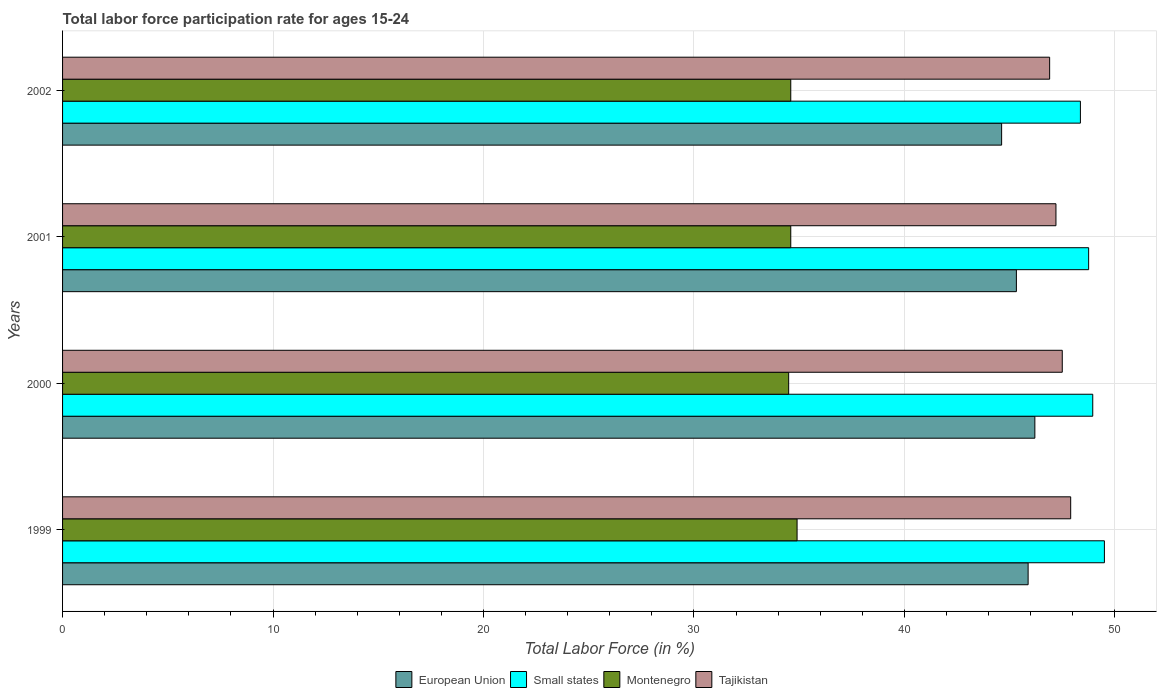Are the number of bars per tick equal to the number of legend labels?
Give a very brief answer. Yes. Are the number of bars on each tick of the Y-axis equal?
Give a very brief answer. Yes. How many bars are there on the 1st tick from the bottom?
Keep it short and to the point. 4. What is the labor force participation rate in European Union in 2000?
Offer a terse response. 46.2. Across all years, what is the maximum labor force participation rate in Small states?
Offer a very short reply. 49.5. Across all years, what is the minimum labor force participation rate in European Union?
Make the answer very short. 44.62. In which year was the labor force participation rate in Small states maximum?
Give a very brief answer. 1999. What is the total labor force participation rate in European Union in the graph?
Provide a short and direct response. 182.01. What is the difference between the labor force participation rate in Tajikistan in 2000 and that in 2001?
Give a very brief answer. 0.3. What is the difference between the labor force participation rate in Tajikistan in 1999 and the labor force participation rate in Montenegro in 2001?
Make the answer very short. 13.3. What is the average labor force participation rate in Small states per year?
Provide a short and direct response. 48.89. In the year 2000, what is the difference between the labor force participation rate in Montenegro and labor force participation rate in European Union?
Ensure brevity in your answer.  -11.7. In how many years, is the labor force participation rate in European Union greater than 2 %?
Offer a very short reply. 4. What is the ratio of the labor force participation rate in Montenegro in 1999 to that in 2002?
Offer a very short reply. 1.01. Is the labor force participation rate in Montenegro in 1999 less than that in 2000?
Provide a short and direct response. No. Is the difference between the labor force participation rate in Montenegro in 1999 and 2001 greater than the difference between the labor force participation rate in European Union in 1999 and 2001?
Provide a succinct answer. No. What is the difference between the highest and the second highest labor force participation rate in European Union?
Ensure brevity in your answer.  0.32. What is the difference between the highest and the lowest labor force participation rate in Tajikistan?
Your response must be concise. 1. In how many years, is the labor force participation rate in Tajikistan greater than the average labor force participation rate in Tajikistan taken over all years?
Your answer should be compact. 2. Is the sum of the labor force participation rate in Montenegro in 2000 and 2002 greater than the maximum labor force participation rate in Tajikistan across all years?
Your response must be concise. Yes. Is it the case that in every year, the sum of the labor force participation rate in European Union and labor force participation rate in Montenegro is greater than the sum of labor force participation rate in Small states and labor force participation rate in Tajikistan?
Offer a terse response. No. What does the 3rd bar from the top in 1999 represents?
Your response must be concise. Small states. What does the 4th bar from the bottom in 2001 represents?
Your answer should be very brief. Tajikistan. Is it the case that in every year, the sum of the labor force participation rate in Montenegro and labor force participation rate in European Union is greater than the labor force participation rate in Tajikistan?
Offer a very short reply. Yes. How many bars are there?
Offer a terse response. 16. What is the difference between two consecutive major ticks on the X-axis?
Make the answer very short. 10. Does the graph contain any zero values?
Make the answer very short. No. Does the graph contain grids?
Keep it short and to the point. Yes. How are the legend labels stacked?
Offer a very short reply. Horizontal. What is the title of the graph?
Your answer should be compact. Total labor force participation rate for ages 15-24. Does "South Asia" appear as one of the legend labels in the graph?
Provide a succinct answer. No. What is the label or title of the Y-axis?
Provide a short and direct response. Years. What is the Total Labor Force (in %) of European Union in 1999?
Keep it short and to the point. 45.88. What is the Total Labor Force (in %) of Small states in 1999?
Keep it short and to the point. 49.5. What is the Total Labor Force (in %) of Montenegro in 1999?
Your response must be concise. 34.9. What is the Total Labor Force (in %) of Tajikistan in 1999?
Your answer should be very brief. 47.9. What is the Total Labor Force (in %) in European Union in 2000?
Make the answer very short. 46.2. What is the Total Labor Force (in %) of Small states in 2000?
Provide a short and direct response. 48.95. What is the Total Labor Force (in %) of Montenegro in 2000?
Give a very brief answer. 34.5. What is the Total Labor Force (in %) in Tajikistan in 2000?
Provide a succinct answer. 47.5. What is the Total Labor Force (in %) of European Union in 2001?
Provide a short and direct response. 45.32. What is the Total Labor Force (in %) in Small states in 2001?
Offer a terse response. 48.75. What is the Total Labor Force (in %) of Montenegro in 2001?
Provide a succinct answer. 34.6. What is the Total Labor Force (in %) in Tajikistan in 2001?
Keep it short and to the point. 47.2. What is the Total Labor Force (in %) in European Union in 2002?
Ensure brevity in your answer.  44.62. What is the Total Labor Force (in %) of Small states in 2002?
Offer a terse response. 48.36. What is the Total Labor Force (in %) of Montenegro in 2002?
Keep it short and to the point. 34.6. What is the Total Labor Force (in %) of Tajikistan in 2002?
Keep it short and to the point. 46.9. Across all years, what is the maximum Total Labor Force (in %) in European Union?
Make the answer very short. 46.2. Across all years, what is the maximum Total Labor Force (in %) in Small states?
Offer a terse response. 49.5. Across all years, what is the maximum Total Labor Force (in %) of Montenegro?
Keep it short and to the point. 34.9. Across all years, what is the maximum Total Labor Force (in %) of Tajikistan?
Your response must be concise. 47.9. Across all years, what is the minimum Total Labor Force (in %) of European Union?
Make the answer very short. 44.62. Across all years, what is the minimum Total Labor Force (in %) in Small states?
Your answer should be compact. 48.36. Across all years, what is the minimum Total Labor Force (in %) of Montenegro?
Offer a terse response. 34.5. Across all years, what is the minimum Total Labor Force (in %) in Tajikistan?
Keep it short and to the point. 46.9. What is the total Total Labor Force (in %) of European Union in the graph?
Provide a succinct answer. 182.01. What is the total Total Labor Force (in %) in Small states in the graph?
Ensure brevity in your answer.  195.56. What is the total Total Labor Force (in %) in Montenegro in the graph?
Ensure brevity in your answer.  138.6. What is the total Total Labor Force (in %) in Tajikistan in the graph?
Provide a short and direct response. 189.5. What is the difference between the Total Labor Force (in %) in European Union in 1999 and that in 2000?
Offer a terse response. -0.32. What is the difference between the Total Labor Force (in %) of Small states in 1999 and that in 2000?
Your response must be concise. 0.55. What is the difference between the Total Labor Force (in %) of European Union in 1999 and that in 2001?
Offer a very short reply. 0.56. What is the difference between the Total Labor Force (in %) of Small states in 1999 and that in 2001?
Offer a terse response. 0.75. What is the difference between the Total Labor Force (in %) in Montenegro in 1999 and that in 2001?
Ensure brevity in your answer.  0.3. What is the difference between the Total Labor Force (in %) of European Union in 1999 and that in 2002?
Offer a terse response. 1.26. What is the difference between the Total Labor Force (in %) of Small states in 1999 and that in 2002?
Your response must be concise. 1.14. What is the difference between the Total Labor Force (in %) in Montenegro in 1999 and that in 2002?
Keep it short and to the point. 0.3. What is the difference between the Total Labor Force (in %) of European Union in 2000 and that in 2001?
Your answer should be compact. 0.88. What is the difference between the Total Labor Force (in %) in Small states in 2000 and that in 2001?
Your answer should be compact. 0.19. What is the difference between the Total Labor Force (in %) in Montenegro in 2000 and that in 2001?
Your answer should be compact. -0.1. What is the difference between the Total Labor Force (in %) in Tajikistan in 2000 and that in 2001?
Provide a short and direct response. 0.3. What is the difference between the Total Labor Force (in %) of European Union in 2000 and that in 2002?
Ensure brevity in your answer.  1.58. What is the difference between the Total Labor Force (in %) of Small states in 2000 and that in 2002?
Keep it short and to the point. 0.59. What is the difference between the Total Labor Force (in %) in European Union in 2001 and that in 2002?
Keep it short and to the point. 0.7. What is the difference between the Total Labor Force (in %) of Small states in 2001 and that in 2002?
Keep it short and to the point. 0.39. What is the difference between the Total Labor Force (in %) in Montenegro in 2001 and that in 2002?
Your answer should be compact. 0. What is the difference between the Total Labor Force (in %) of Tajikistan in 2001 and that in 2002?
Keep it short and to the point. 0.3. What is the difference between the Total Labor Force (in %) of European Union in 1999 and the Total Labor Force (in %) of Small states in 2000?
Your answer should be compact. -3.07. What is the difference between the Total Labor Force (in %) in European Union in 1999 and the Total Labor Force (in %) in Montenegro in 2000?
Provide a short and direct response. 11.38. What is the difference between the Total Labor Force (in %) of European Union in 1999 and the Total Labor Force (in %) of Tajikistan in 2000?
Your answer should be compact. -1.62. What is the difference between the Total Labor Force (in %) in Small states in 1999 and the Total Labor Force (in %) in Montenegro in 2000?
Ensure brevity in your answer.  15. What is the difference between the Total Labor Force (in %) of Small states in 1999 and the Total Labor Force (in %) of Tajikistan in 2000?
Give a very brief answer. 2. What is the difference between the Total Labor Force (in %) in European Union in 1999 and the Total Labor Force (in %) in Small states in 2001?
Give a very brief answer. -2.88. What is the difference between the Total Labor Force (in %) in European Union in 1999 and the Total Labor Force (in %) in Montenegro in 2001?
Your answer should be compact. 11.28. What is the difference between the Total Labor Force (in %) of European Union in 1999 and the Total Labor Force (in %) of Tajikistan in 2001?
Your answer should be compact. -1.32. What is the difference between the Total Labor Force (in %) in Small states in 1999 and the Total Labor Force (in %) in Montenegro in 2001?
Make the answer very short. 14.9. What is the difference between the Total Labor Force (in %) of Small states in 1999 and the Total Labor Force (in %) of Tajikistan in 2001?
Make the answer very short. 2.3. What is the difference between the Total Labor Force (in %) in European Union in 1999 and the Total Labor Force (in %) in Small states in 2002?
Give a very brief answer. -2.48. What is the difference between the Total Labor Force (in %) in European Union in 1999 and the Total Labor Force (in %) in Montenegro in 2002?
Ensure brevity in your answer.  11.28. What is the difference between the Total Labor Force (in %) in European Union in 1999 and the Total Labor Force (in %) in Tajikistan in 2002?
Your response must be concise. -1.02. What is the difference between the Total Labor Force (in %) in Small states in 1999 and the Total Labor Force (in %) in Montenegro in 2002?
Offer a very short reply. 14.9. What is the difference between the Total Labor Force (in %) in Small states in 1999 and the Total Labor Force (in %) in Tajikistan in 2002?
Offer a terse response. 2.6. What is the difference between the Total Labor Force (in %) in European Union in 2000 and the Total Labor Force (in %) in Small states in 2001?
Ensure brevity in your answer.  -2.56. What is the difference between the Total Labor Force (in %) in European Union in 2000 and the Total Labor Force (in %) in Montenegro in 2001?
Ensure brevity in your answer.  11.6. What is the difference between the Total Labor Force (in %) in European Union in 2000 and the Total Labor Force (in %) in Tajikistan in 2001?
Offer a very short reply. -1. What is the difference between the Total Labor Force (in %) in Small states in 2000 and the Total Labor Force (in %) in Montenegro in 2001?
Your answer should be very brief. 14.35. What is the difference between the Total Labor Force (in %) in Small states in 2000 and the Total Labor Force (in %) in Tajikistan in 2001?
Make the answer very short. 1.75. What is the difference between the Total Labor Force (in %) in European Union in 2000 and the Total Labor Force (in %) in Small states in 2002?
Make the answer very short. -2.16. What is the difference between the Total Labor Force (in %) of European Union in 2000 and the Total Labor Force (in %) of Montenegro in 2002?
Make the answer very short. 11.6. What is the difference between the Total Labor Force (in %) of European Union in 2000 and the Total Labor Force (in %) of Tajikistan in 2002?
Ensure brevity in your answer.  -0.7. What is the difference between the Total Labor Force (in %) in Small states in 2000 and the Total Labor Force (in %) in Montenegro in 2002?
Provide a succinct answer. 14.35. What is the difference between the Total Labor Force (in %) in Small states in 2000 and the Total Labor Force (in %) in Tajikistan in 2002?
Provide a succinct answer. 2.05. What is the difference between the Total Labor Force (in %) of Montenegro in 2000 and the Total Labor Force (in %) of Tajikistan in 2002?
Your answer should be compact. -12.4. What is the difference between the Total Labor Force (in %) in European Union in 2001 and the Total Labor Force (in %) in Small states in 2002?
Give a very brief answer. -3.04. What is the difference between the Total Labor Force (in %) in European Union in 2001 and the Total Labor Force (in %) in Montenegro in 2002?
Provide a succinct answer. 10.72. What is the difference between the Total Labor Force (in %) in European Union in 2001 and the Total Labor Force (in %) in Tajikistan in 2002?
Your answer should be very brief. -1.58. What is the difference between the Total Labor Force (in %) in Small states in 2001 and the Total Labor Force (in %) in Montenegro in 2002?
Ensure brevity in your answer.  14.15. What is the difference between the Total Labor Force (in %) in Small states in 2001 and the Total Labor Force (in %) in Tajikistan in 2002?
Provide a succinct answer. 1.85. What is the difference between the Total Labor Force (in %) in Montenegro in 2001 and the Total Labor Force (in %) in Tajikistan in 2002?
Your response must be concise. -12.3. What is the average Total Labor Force (in %) of European Union per year?
Your answer should be very brief. 45.5. What is the average Total Labor Force (in %) in Small states per year?
Keep it short and to the point. 48.89. What is the average Total Labor Force (in %) of Montenegro per year?
Your answer should be compact. 34.65. What is the average Total Labor Force (in %) of Tajikistan per year?
Offer a very short reply. 47.38. In the year 1999, what is the difference between the Total Labor Force (in %) of European Union and Total Labor Force (in %) of Small states?
Your answer should be very brief. -3.62. In the year 1999, what is the difference between the Total Labor Force (in %) in European Union and Total Labor Force (in %) in Montenegro?
Your answer should be compact. 10.98. In the year 1999, what is the difference between the Total Labor Force (in %) in European Union and Total Labor Force (in %) in Tajikistan?
Offer a terse response. -2.02. In the year 1999, what is the difference between the Total Labor Force (in %) in Small states and Total Labor Force (in %) in Montenegro?
Provide a succinct answer. 14.6. In the year 1999, what is the difference between the Total Labor Force (in %) in Small states and Total Labor Force (in %) in Tajikistan?
Provide a succinct answer. 1.6. In the year 1999, what is the difference between the Total Labor Force (in %) in Montenegro and Total Labor Force (in %) in Tajikistan?
Ensure brevity in your answer.  -13. In the year 2000, what is the difference between the Total Labor Force (in %) of European Union and Total Labor Force (in %) of Small states?
Your answer should be very brief. -2.75. In the year 2000, what is the difference between the Total Labor Force (in %) in European Union and Total Labor Force (in %) in Montenegro?
Your response must be concise. 11.7. In the year 2000, what is the difference between the Total Labor Force (in %) of European Union and Total Labor Force (in %) of Tajikistan?
Provide a short and direct response. -1.3. In the year 2000, what is the difference between the Total Labor Force (in %) in Small states and Total Labor Force (in %) in Montenegro?
Your answer should be very brief. 14.45. In the year 2000, what is the difference between the Total Labor Force (in %) of Small states and Total Labor Force (in %) of Tajikistan?
Your response must be concise. 1.45. In the year 2000, what is the difference between the Total Labor Force (in %) in Montenegro and Total Labor Force (in %) in Tajikistan?
Offer a terse response. -13. In the year 2001, what is the difference between the Total Labor Force (in %) in European Union and Total Labor Force (in %) in Small states?
Offer a very short reply. -3.43. In the year 2001, what is the difference between the Total Labor Force (in %) in European Union and Total Labor Force (in %) in Montenegro?
Give a very brief answer. 10.72. In the year 2001, what is the difference between the Total Labor Force (in %) of European Union and Total Labor Force (in %) of Tajikistan?
Your answer should be compact. -1.88. In the year 2001, what is the difference between the Total Labor Force (in %) of Small states and Total Labor Force (in %) of Montenegro?
Your answer should be very brief. 14.15. In the year 2001, what is the difference between the Total Labor Force (in %) of Small states and Total Labor Force (in %) of Tajikistan?
Make the answer very short. 1.55. In the year 2002, what is the difference between the Total Labor Force (in %) of European Union and Total Labor Force (in %) of Small states?
Provide a succinct answer. -3.74. In the year 2002, what is the difference between the Total Labor Force (in %) in European Union and Total Labor Force (in %) in Montenegro?
Your answer should be very brief. 10.02. In the year 2002, what is the difference between the Total Labor Force (in %) in European Union and Total Labor Force (in %) in Tajikistan?
Offer a terse response. -2.28. In the year 2002, what is the difference between the Total Labor Force (in %) in Small states and Total Labor Force (in %) in Montenegro?
Offer a very short reply. 13.76. In the year 2002, what is the difference between the Total Labor Force (in %) of Small states and Total Labor Force (in %) of Tajikistan?
Offer a very short reply. 1.46. What is the ratio of the Total Labor Force (in %) in European Union in 1999 to that in 2000?
Give a very brief answer. 0.99. What is the ratio of the Total Labor Force (in %) in Small states in 1999 to that in 2000?
Give a very brief answer. 1.01. What is the ratio of the Total Labor Force (in %) in Montenegro in 1999 to that in 2000?
Offer a very short reply. 1.01. What is the ratio of the Total Labor Force (in %) in Tajikistan in 1999 to that in 2000?
Make the answer very short. 1.01. What is the ratio of the Total Labor Force (in %) in European Union in 1999 to that in 2001?
Your response must be concise. 1.01. What is the ratio of the Total Labor Force (in %) in Small states in 1999 to that in 2001?
Keep it short and to the point. 1.02. What is the ratio of the Total Labor Force (in %) in Montenegro in 1999 to that in 2001?
Give a very brief answer. 1.01. What is the ratio of the Total Labor Force (in %) of Tajikistan in 1999 to that in 2001?
Make the answer very short. 1.01. What is the ratio of the Total Labor Force (in %) of European Union in 1999 to that in 2002?
Your response must be concise. 1.03. What is the ratio of the Total Labor Force (in %) in Small states in 1999 to that in 2002?
Your response must be concise. 1.02. What is the ratio of the Total Labor Force (in %) of Montenegro in 1999 to that in 2002?
Give a very brief answer. 1.01. What is the ratio of the Total Labor Force (in %) in Tajikistan in 1999 to that in 2002?
Offer a very short reply. 1.02. What is the ratio of the Total Labor Force (in %) in European Union in 2000 to that in 2001?
Give a very brief answer. 1.02. What is the ratio of the Total Labor Force (in %) in Tajikistan in 2000 to that in 2001?
Provide a short and direct response. 1.01. What is the ratio of the Total Labor Force (in %) of European Union in 2000 to that in 2002?
Provide a short and direct response. 1.04. What is the ratio of the Total Labor Force (in %) in Small states in 2000 to that in 2002?
Provide a succinct answer. 1.01. What is the ratio of the Total Labor Force (in %) of Tajikistan in 2000 to that in 2002?
Provide a succinct answer. 1.01. What is the ratio of the Total Labor Force (in %) of European Union in 2001 to that in 2002?
Ensure brevity in your answer.  1.02. What is the ratio of the Total Labor Force (in %) of Small states in 2001 to that in 2002?
Make the answer very short. 1.01. What is the ratio of the Total Labor Force (in %) of Tajikistan in 2001 to that in 2002?
Keep it short and to the point. 1.01. What is the difference between the highest and the second highest Total Labor Force (in %) of European Union?
Offer a very short reply. 0.32. What is the difference between the highest and the second highest Total Labor Force (in %) in Small states?
Keep it short and to the point. 0.55. What is the difference between the highest and the second highest Total Labor Force (in %) of Montenegro?
Offer a very short reply. 0.3. What is the difference between the highest and the lowest Total Labor Force (in %) in European Union?
Offer a very short reply. 1.58. What is the difference between the highest and the lowest Total Labor Force (in %) in Small states?
Your response must be concise. 1.14. What is the difference between the highest and the lowest Total Labor Force (in %) of Montenegro?
Offer a very short reply. 0.4. 